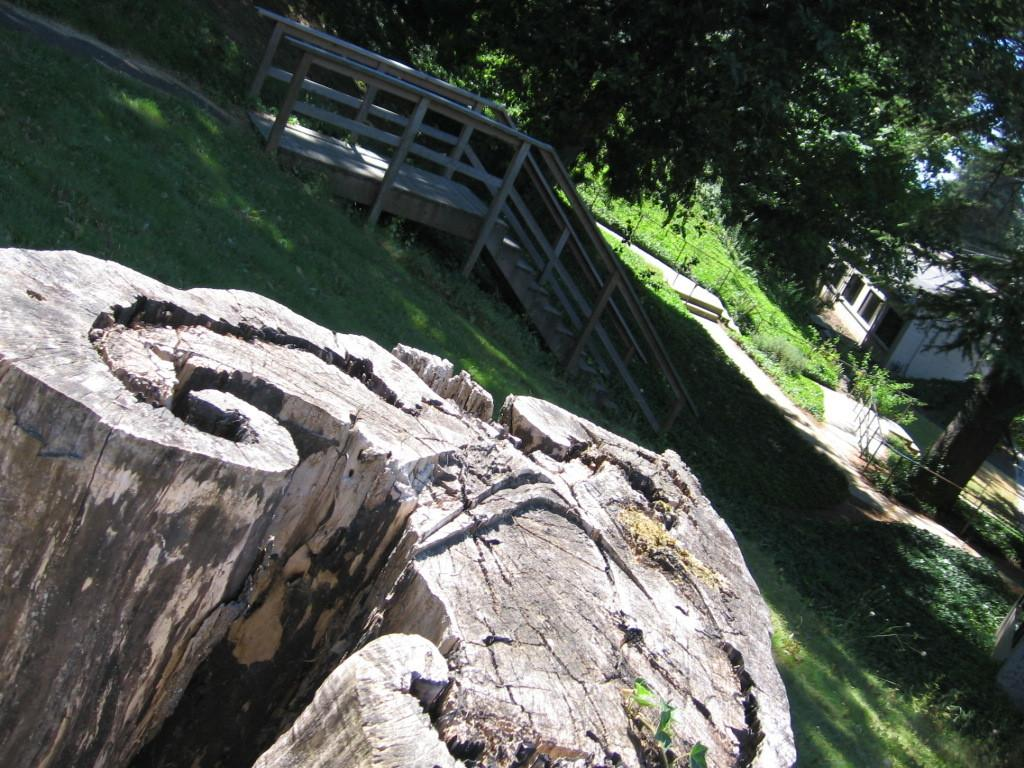What is located in the foreground of the image? In the foreground of the image, there is a tree trunk, grass, and a staircase. What can be seen in the background of the image? In the background of the image, there are plants, trees, a fence, and a house. What is the weather like in the image? The image was likely taken during a sunny day, as indicated by the bright lighting and clear sky. What type of juice is being served in the tent in the image? There is no tent or juice present in the image. How many muscles are visible on the tree trunk in the image? Trees do not have muscles, so this question is not applicable to the image. 